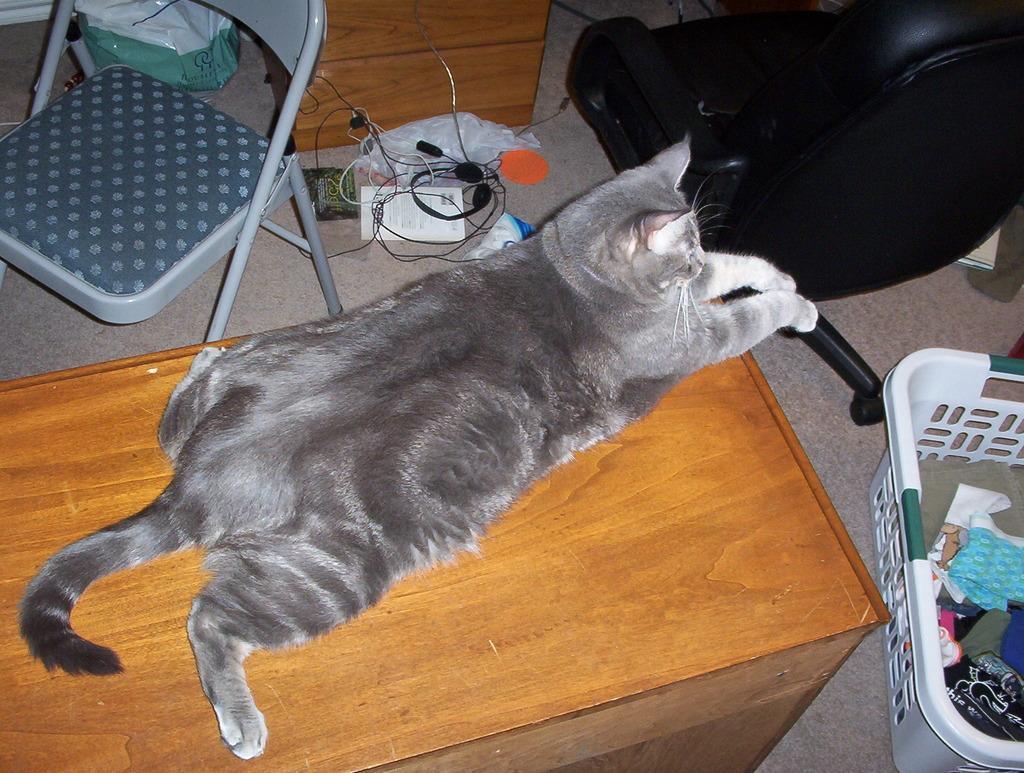How would you summarize this image in a sentence or two? We can see a cat on the desk. At the right side of the picture we can see a chair in black color and a basket of clothes. Here we can see headphones , book , paper. Here we can see an empty chair and also a plastic carry bag. This is a floor. 